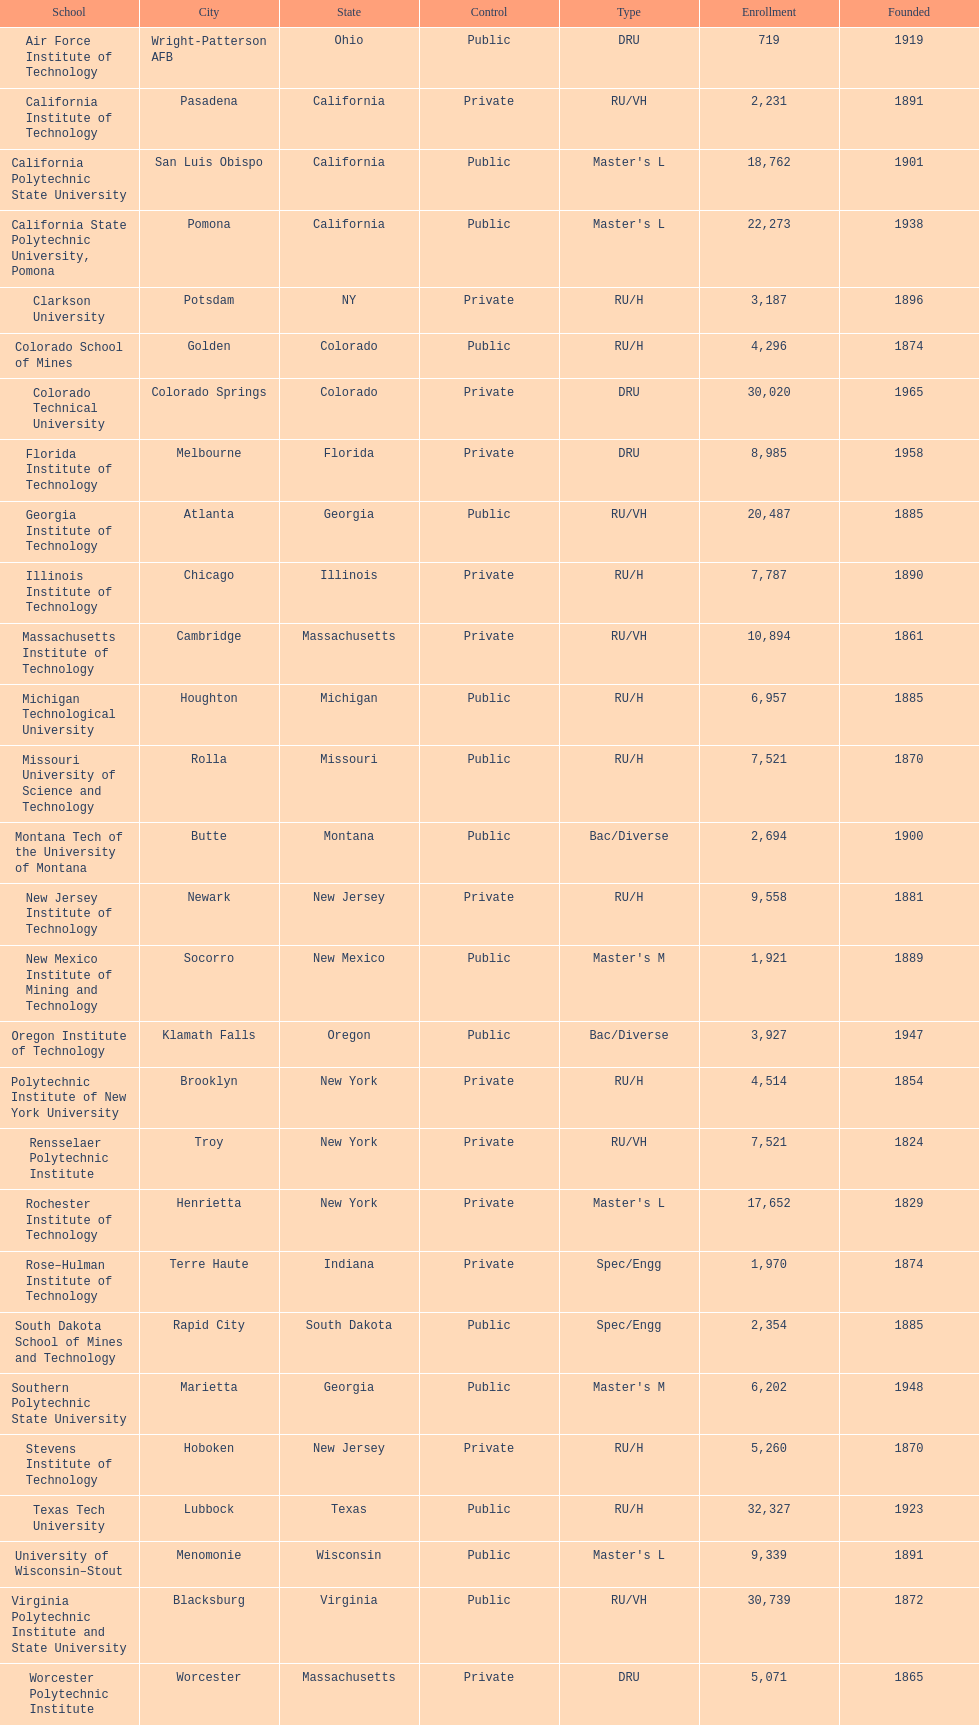What technical universities are in the united states? Air Force Institute of Technology, California Institute of Technology, California Polytechnic State University, California State Polytechnic University, Pomona, Clarkson University, Colorado School of Mines, Colorado Technical University, Florida Institute of Technology, Georgia Institute of Technology, Illinois Institute of Technology, Massachusetts Institute of Technology, Michigan Technological University, Missouri University of Science and Technology, Montana Tech of the University of Montana, New Jersey Institute of Technology, New Mexico Institute of Mining and Technology, Oregon Institute of Technology, Polytechnic Institute of New York University, Rensselaer Polytechnic Institute, Rochester Institute of Technology, Rose–Hulman Institute of Technology, South Dakota School of Mines and Technology, Southern Polytechnic State University, Stevens Institute of Technology, Texas Tech University, University of Wisconsin–Stout, Virginia Polytechnic Institute and State University, Worcester Polytechnic Institute. Which has the highest enrollment? Texas Tech University. 